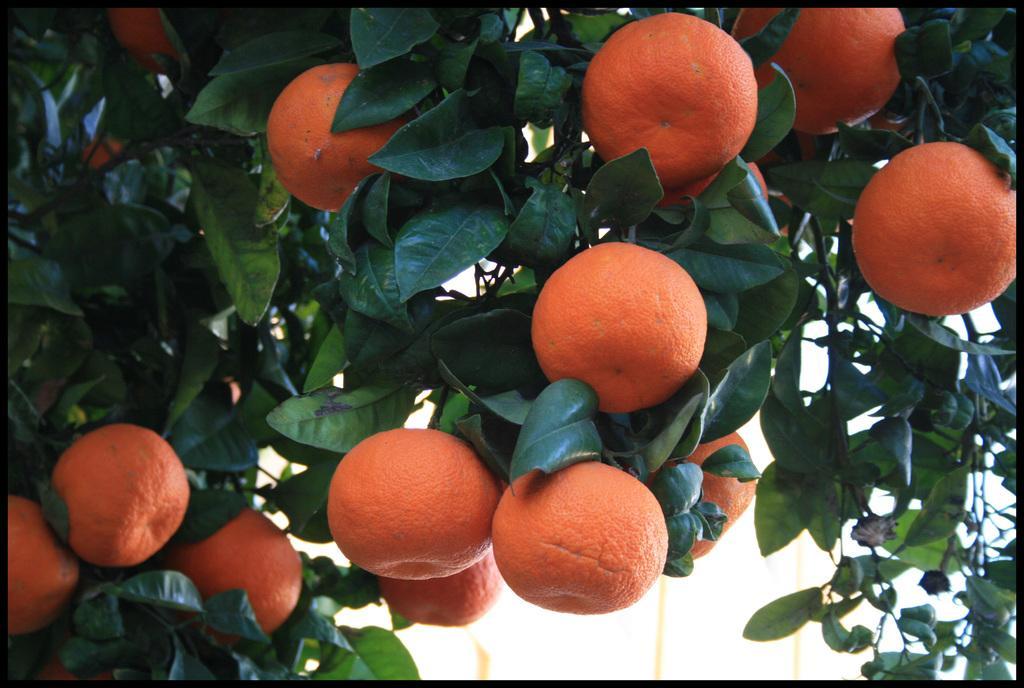Please provide a concise description of this image. There is a tree, which is having orange fruits, which are in orange color. In the background, there is a white wall. 